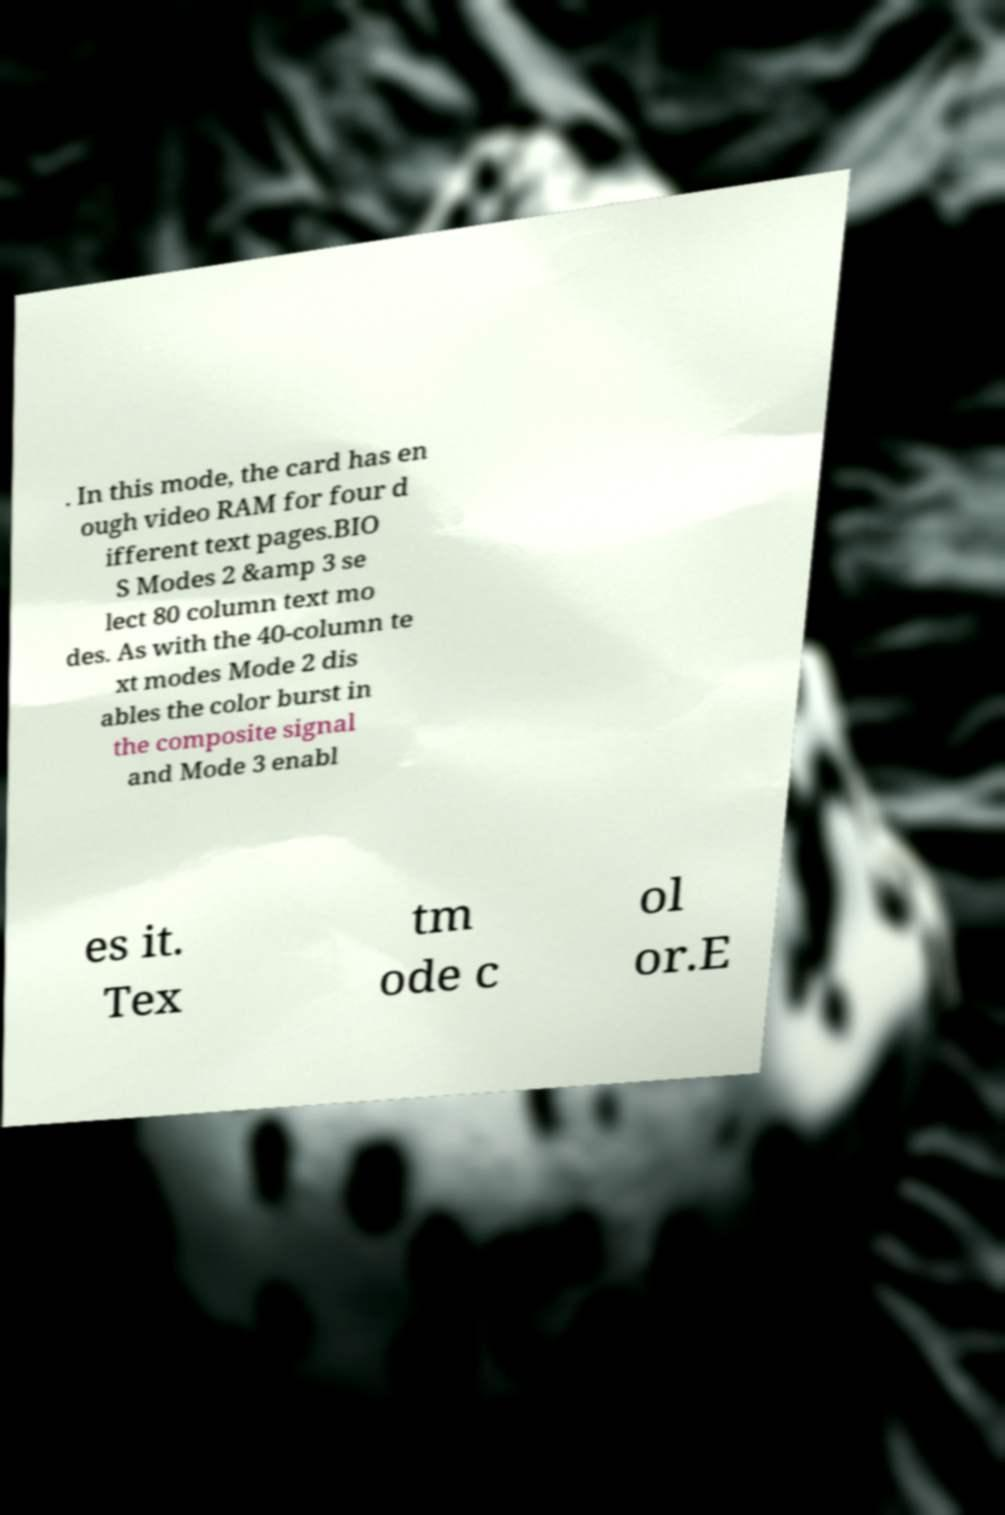Please identify and transcribe the text found in this image. . In this mode, the card has en ough video RAM for four d ifferent text pages.BIO S Modes 2 &amp 3 se lect 80 column text mo des. As with the 40-column te xt modes Mode 2 dis ables the color burst in the composite signal and Mode 3 enabl es it. Tex tm ode c ol or.E 